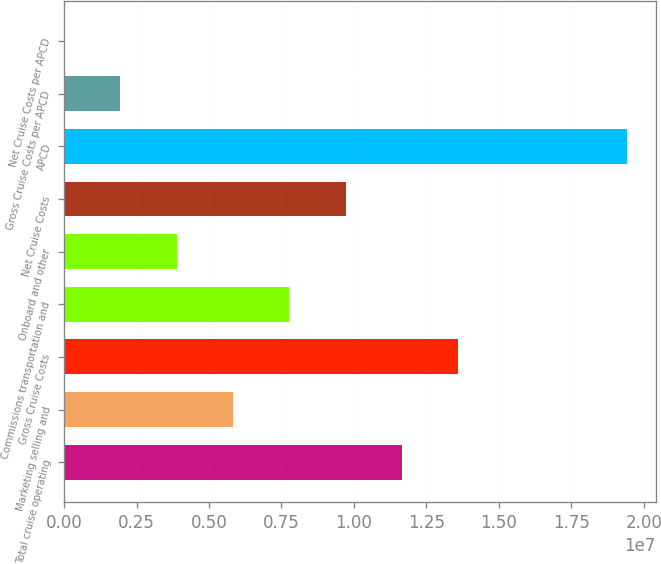<chart> <loc_0><loc_0><loc_500><loc_500><bar_chart><fcel>Total cruise operating<fcel>Marketing selling and<fcel>Gross Cruise Costs<fcel>Commissions transportation and<fcel>Onboard and other<fcel>Net Cruise Costs<fcel>APCD<fcel>Gross Cruise Costs per APCD<fcel>Net Cruise Costs per APCD<nl><fcel>1.16636e+07<fcel>5.83184e+06<fcel>1.36075e+07<fcel>7.77576e+06<fcel>3.88793e+06<fcel>9.71967e+06<fcel>1.94392e+07<fcel>1.94401e+06<fcel>100.9<nl></chart> 